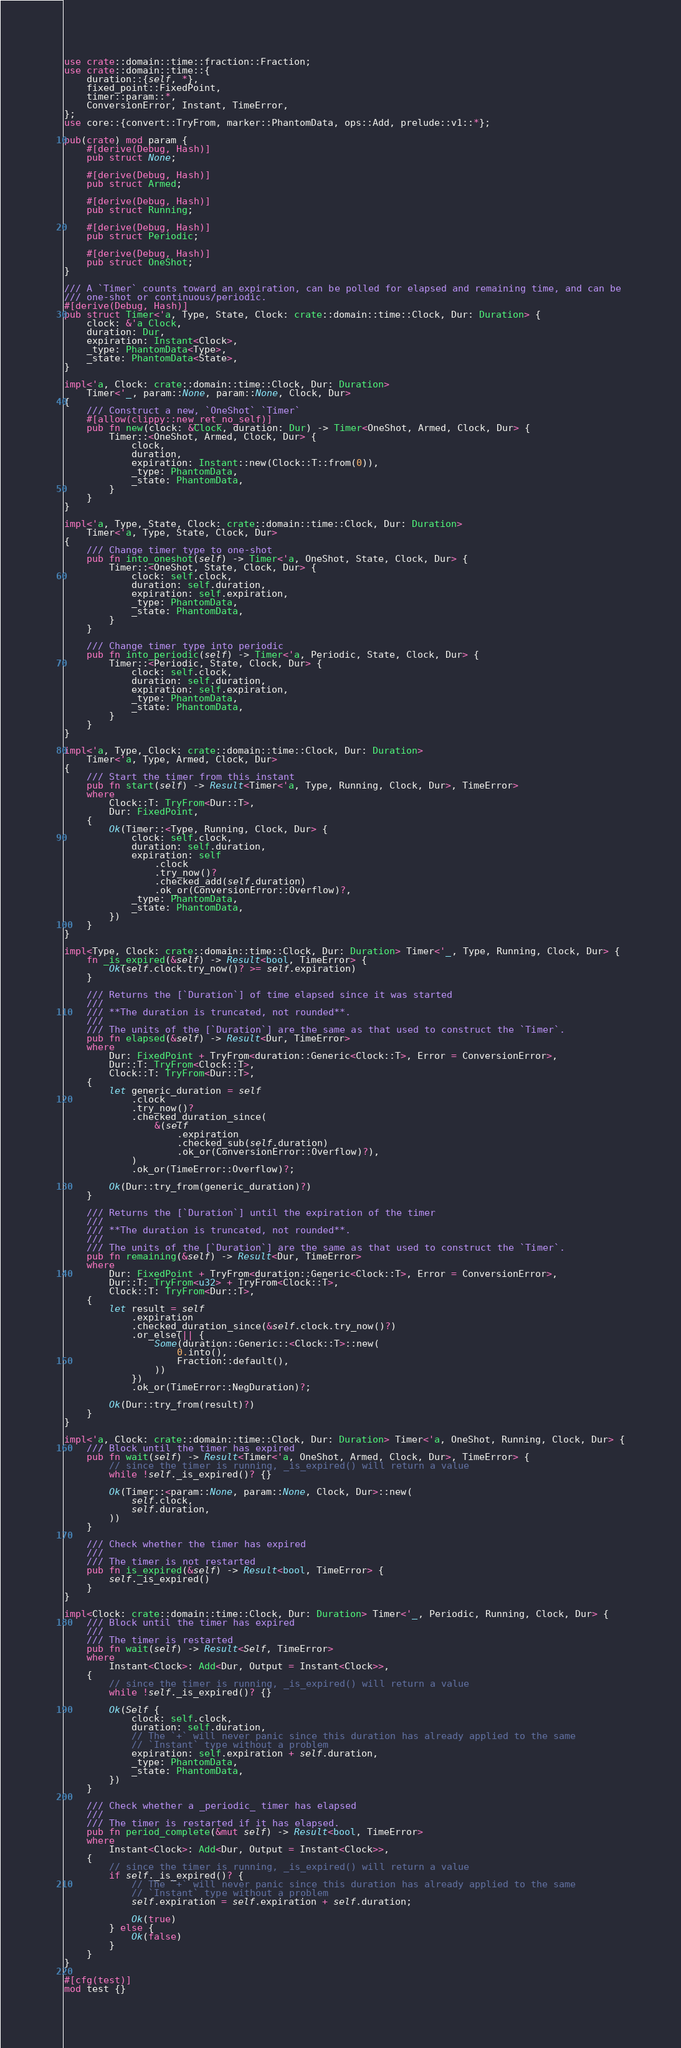Convert code to text. <code><loc_0><loc_0><loc_500><loc_500><_Rust_>use crate::domain::time::fraction::Fraction;
use crate::domain::time::{
    duration::{self, *},
    fixed_point::FixedPoint,
    timer::param::*,
    ConversionError, Instant, TimeError,
};
use core::{convert::TryFrom, marker::PhantomData, ops::Add, prelude::v1::*};

pub(crate) mod param {
    #[derive(Debug, Hash)]
    pub struct None;

    #[derive(Debug, Hash)]
    pub struct Armed;

    #[derive(Debug, Hash)]
    pub struct Running;

    #[derive(Debug, Hash)]
    pub struct Periodic;

    #[derive(Debug, Hash)]
    pub struct OneShot;
}

/// A `Timer` counts toward an expiration, can be polled for elapsed and remaining time, and can be
/// one-shot or continuous/periodic.
#[derive(Debug, Hash)]
pub struct Timer<'a, Type, State, Clock: crate::domain::time::Clock, Dur: Duration> {
    clock: &'a Clock,
    duration: Dur,
    expiration: Instant<Clock>,
    _type: PhantomData<Type>,
    _state: PhantomData<State>,
}

impl<'a, Clock: crate::domain::time::Clock, Dur: Duration>
    Timer<'_, param::None, param::None, Clock, Dur>
{
    /// Construct a new, `OneShot` `Timer`
    #[allow(clippy::new_ret_no_self)]
    pub fn new(clock: &Clock, duration: Dur) -> Timer<OneShot, Armed, Clock, Dur> {
        Timer::<OneShot, Armed, Clock, Dur> {
            clock,
            duration,
            expiration: Instant::new(Clock::T::from(0)),
            _type: PhantomData,
            _state: PhantomData,
        }
    }
}

impl<'a, Type, State, Clock: crate::domain::time::Clock, Dur: Duration>
    Timer<'a, Type, State, Clock, Dur>
{
    /// Change timer type to one-shot
    pub fn into_oneshot(self) -> Timer<'a, OneShot, State, Clock, Dur> {
        Timer::<OneShot, State, Clock, Dur> {
            clock: self.clock,
            duration: self.duration,
            expiration: self.expiration,
            _type: PhantomData,
            _state: PhantomData,
        }
    }

    /// Change timer type into periodic
    pub fn into_periodic(self) -> Timer<'a, Periodic, State, Clock, Dur> {
        Timer::<Periodic, State, Clock, Dur> {
            clock: self.clock,
            duration: self.duration,
            expiration: self.expiration,
            _type: PhantomData,
            _state: PhantomData,
        }
    }
}

impl<'a, Type, Clock: crate::domain::time::Clock, Dur: Duration>
    Timer<'a, Type, Armed, Clock, Dur>
{
    /// Start the timer from this instant
    pub fn start(self) -> Result<Timer<'a, Type, Running, Clock, Dur>, TimeError>
    where
        Clock::T: TryFrom<Dur::T>,
        Dur: FixedPoint,
    {
        Ok(Timer::<Type, Running, Clock, Dur> {
            clock: self.clock,
            duration: self.duration,
            expiration: self
                .clock
                .try_now()?
                .checked_add(self.duration)
                .ok_or(ConversionError::Overflow)?,
            _type: PhantomData,
            _state: PhantomData,
        })
    }
}

impl<Type, Clock: crate::domain::time::Clock, Dur: Duration> Timer<'_, Type, Running, Clock, Dur> {
    fn _is_expired(&self) -> Result<bool, TimeError> {
        Ok(self.clock.try_now()? >= self.expiration)
    }

    /// Returns the [`Duration`] of time elapsed since it was started
    ///
    /// **The duration is truncated, not rounded**.
    ///
    /// The units of the [`Duration`] are the same as that used to construct the `Timer`.
    pub fn elapsed(&self) -> Result<Dur, TimeError>
    where
        Dur: FixedPoint + TryFrom<duration::Generic<Clock::T>, Error = ConversionError>,
        Dur::T: TryFrom<Clock::T>,
        Clock::T: TryFrom<Dur::T>,
    {
        let generic_duration = self
            .clock
            .try_now()?
            .checked_duration_since(
                &(self
                    .expiration
                    .checked_sub(self.duration)
                    .ok_or(ConversionError::Overflow)?),
            )
            .ok_or(TimeError::Overflow)?;

        Ok(Dur::try_from(generic_duration)?)
    }

    /// Returns the [`Duration`] until the expiration of the timer
    ///
    /// **The duration is truncated, not rounded**.
    ///
    /// The units of the [`Duration`] are the same as that used to construct the `Timer`.
    pub fn remaining(&self) -> Result<Dur, TimeError>
    where
        Dur: FixedPoint + TryFrom<duration::Generic<Clock::T>, Error = ConversionError>,
        Dur::T: TryFrom<u32> + TryFrom<Clock::T>,
        Clock::T: TryFrom<Dur::T>,
    {
        let result = self
            .expiration
            .checked_duration_since(&self.clock.try_now()?)
            .or_else(|| {
                Some(duration::Generic::<Clock::T>::new(
                    0.into(),
                    Fraction::default(),
                ))
            })
            .ok_or(TimeError::NegDuration)?;

        Ok(Dur::try_from(result)?)
    }
}

impl<'a, Clock: crate::domain::time::Clock, Dur: Duration> Timer<'a, OneShot, Running, Clock, Dur> {
    /// Block until the timer has expired
    pub fn wait(self) -> Result<Timer<'a, OneShot, Armed, Clock, Dur>, TimeError> {
        // since the timer is running, _is_expired() will return a value
        while !self._is_expired()? {}

        Ok(Timer::<param::None, param::None, Clock, Dur>::new(
            self.clock,
            self.duration,
        ))
    }

    /// Check whether the timer has expired
    ///
    /// The timer is not restarted
    pub fn is_expired(&self) -> Result<bool, TimeError> {
        self._is_expired()
    }
}

impl<Clock: crate::domain::time::Clock, Dur: Duration> Timer<'_, Periodic, Running, Clock, Dur> {
    /// Block until the timer has expired
    ///
    /// The timer is restarted
    pub fn wait(self) -> Result<Self, TimeError>
    where
        Instant<Clock>: Add<Dur, Output = Instant<Clock>>,
    {
        // since the timer is running, _is_expired() will return a value
        while !self._is_expired()? {}

        Ok(Self {
            clock: self.clock,
            duration: self.duration,
            // The `+` will never panic since this duration has already applied to the same
            // `Instant` type without a problem
            expiration: self.expiration + self.duration,
            _type: PhantomData,
            _state: PhantomData,
        })
    }

    /// Check whether a _periodic_ timer has elapsed
    ///
    /// The timer is restarted if it has elapsed.
    pub fn period_complete(&mut self) -> Result<bool, TimeError>
    where
        Instant<Clock>: Add<Dur, Output = Instant<Clock>>,
    {
        // since the timer is running, _is_expired() will return a value
        if self._is_expired()? {
            // The `+` will never panic since this duration has already applied to the same
            // `Instant` type without a problem
            self.expiration = self.expiration + self.duration;

            Ok(true)
        } else {
            Ok(false)
        }
    }
}

#[cfg(test)]
mod test {}
</code> 